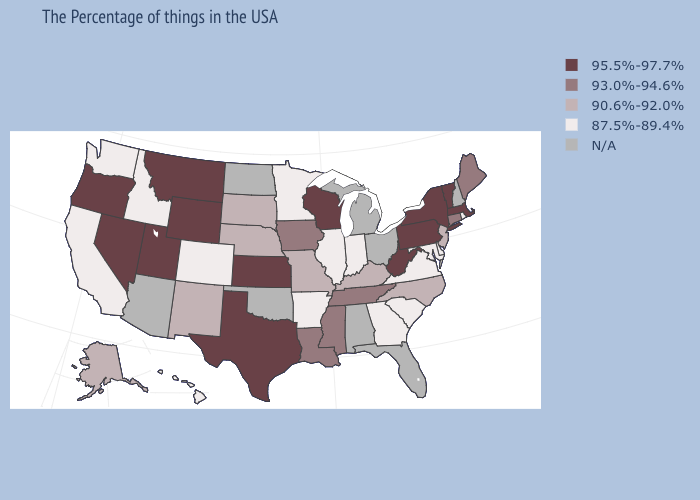What is the value of Wyoming?
Keep it brief. 95.5%-97.7%. Is the legend a continuous bar?
Be succinct. No. Does the map have missing data?
Keep it brief. Yes. What is the value of Virginia?
Be succinct. 87.5%-89.4%. What is the lowest value in the USA?
Concise answer only. 87.5%-89.4%. Does New Jersey have the highest value in the Northeast?
Answer briefly. No. Among the states that border Arizona , which have the highest value?
Concise answer only. Utah, Nevada. Does Nebraska have the lowest value in the USA?
Write a very short answer. No. Does Pennsylvania have the lowest value in the USA?
Be succinct. No. What is the value of South Carolina?
Be succinct. 87.5%-89.4%. What is the value of Mississippi?
Write a very short answer. 93.0%-94.6%. How many symbols are there in the legend?
Answer briefly. 5. Which states have the lowest value in the Northeast?
Short answer required. Rhode Island. What is the lowest value in states that border Pennsylvania?
Write a very short answer. 87.5%-89.4%. 